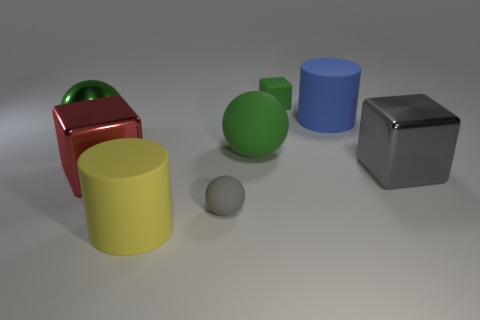There is a large object that is the same color as the big metal sphere; what is it made of?
Make the answer very short. Rubber. Is the number of large blue things on the right side of the blue cylinder less than the number of large blue objects on the left side of the red cube?
Keep it short and to the point. No. What number of other objects are the same material as the blue object?
Provide a short and direct response. 4. What is the material of the gray object that is the same size as the yellow matte cylinder?
Provide a short and direct response. Metal. How many brown things are shiny spheres or tiny spheres?
Offer a terse response. 0. There is a thing that is both on the left side of the tiny gray rubber object and in front of the red object; what color is it?
Your response must be concise. Yellow. Do the object that is on the left side of the red shiny cube and the green thing that is in front of the green shiny thing have the same material?
Make the answer very short. No. Are there more big green matte objects behind the large blue rubber thing than tiny gray rubber balls behind the gray rubber object?
Provide a succinct answer. No. What shape is the green matte thing that is the same size as the gray matte ball?
Your answer should be compact. Cube. How many things are either blocks or big cubes that are on the right side of the gray rubber object?
Give a very brief answer. 3. 